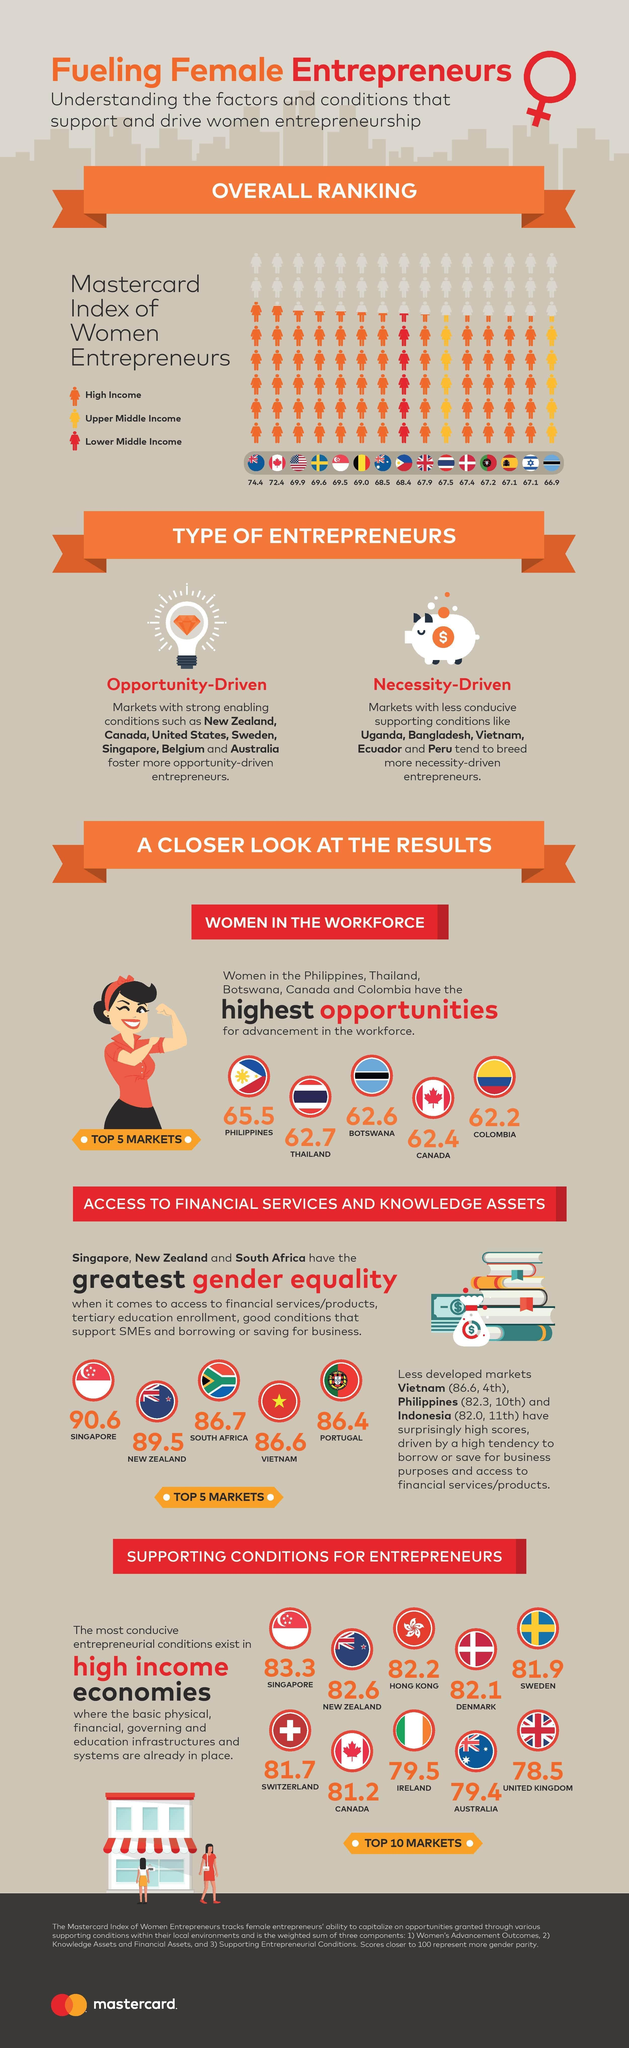Which country come fourth in providing higher opportunities for women?
Answer the question with a short phrase. Canada Which country has the second highest high income business women ? Canada What is the score of Hong Kong in income generation? 82.2 Which is the only country that has business women earning lower middle income? Phillipines What is the Mastercard Index of women entrepreneurs in Sweden? 69.6 Which country takes the eighth place in high income economies? Ireland What is the score of Portugal in gender equality, 90.6, 86.7, or 86.4? 86.4 Which two countries have business women earning upper middle income? Thailand, Botswana 